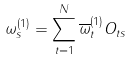Convert formula to latex. <formula><loc_0><loc_0><loc_500><loc_500>\omega _ { s } ^ { ( 1 ) } = \sum _ { t = 1 } ^ { N } \overline { \omega } _ { t } ^ { ( 1 ) } O _ { t s }</formula> 